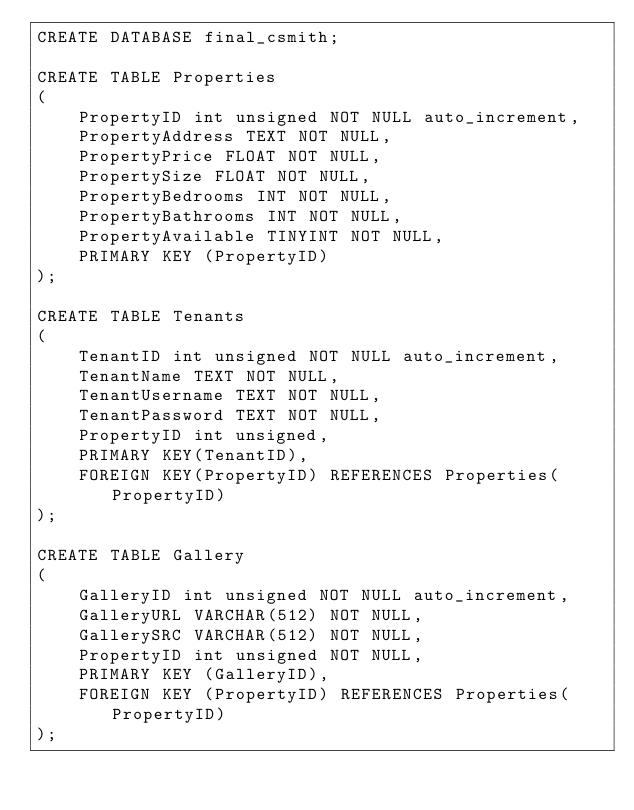<code> <loc_0><loc_0><loc_500><loc_500><_SQL_>CREATE DATABASE final_csmith;

CREATE TABLE Properties
(
    PropertyID int unsigned NOT NULL auto_increment,
    PropertyAddress TEXT NOT NULL,
    PropertyPrice FLOAT NOT NULL,
    PropertySize FLOAT NOT NULL,
    PropertyBedrooms INT NOT NULL,
    PropertyBathrooms INT NOT NULL,
    PropertyAvailable TINYINT NOT NULL,
    PRIMARY KEY (PropertyID)
);

CREATE TABLE Tenants
(
    TenantID int unsigned NOT NULL auto_increment,
    TenantName TEXT NOT NULL,
    TenantUsername TEXT NOT NULL,
    TenantPassword TEXT NOT NULL,
    PropertyID int unsigned,
    PRIMARY KEY(TenantID),
    FOREIGN KEY(PropertyID) REFERENCES Properties(PropertyID)
);

CREATE TABLE Gallery
(
    GalleryID int unsigned NOT NULL auto_increment,
    GalleryURL VARCHAR(512) NOT NULL,
    GallerySRC VARCHAR(512) NOT NULL,
    PropertyID int unsigned NOT NULL,
    PRIMARY KEY (GalleryID),
    FOREIGN KEY (PropertyID) REFERENCES Properties(PropertyID)
);</code> 